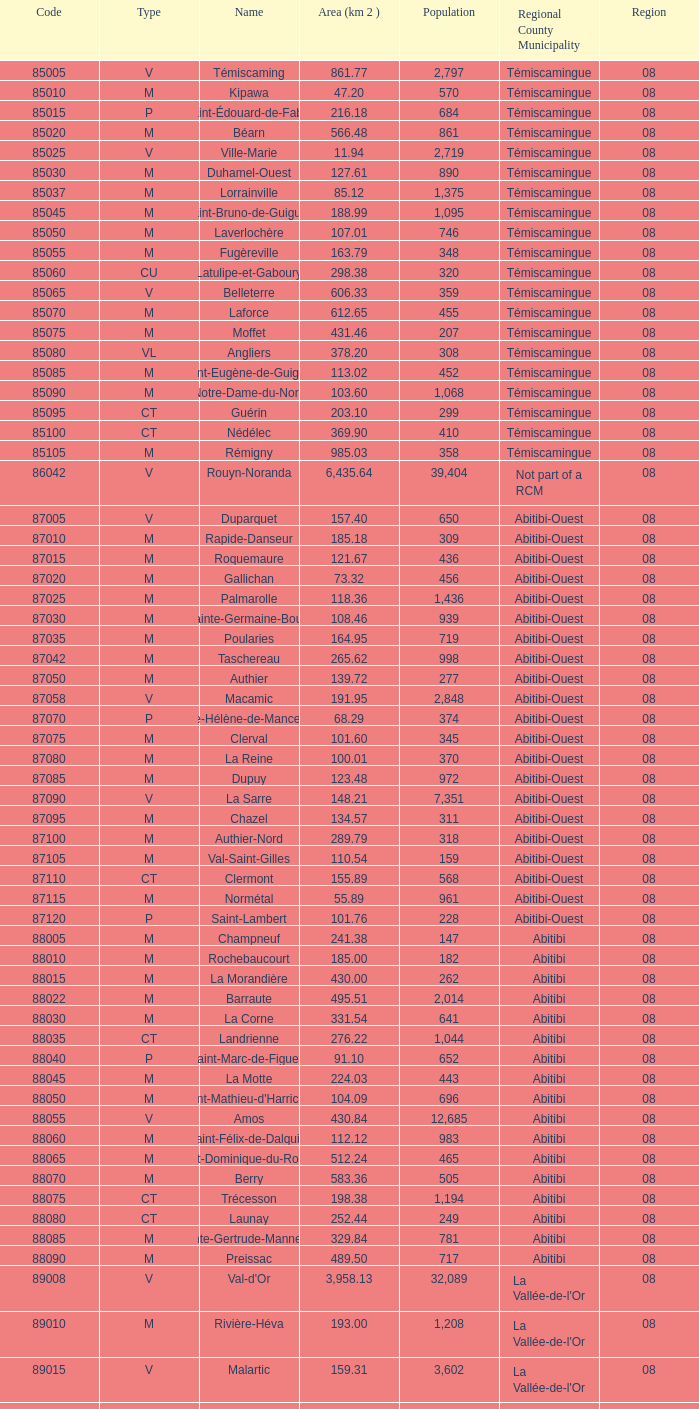What municipality has 719 people and is larger than 108.46 km2? Abitibi-Ouest. 